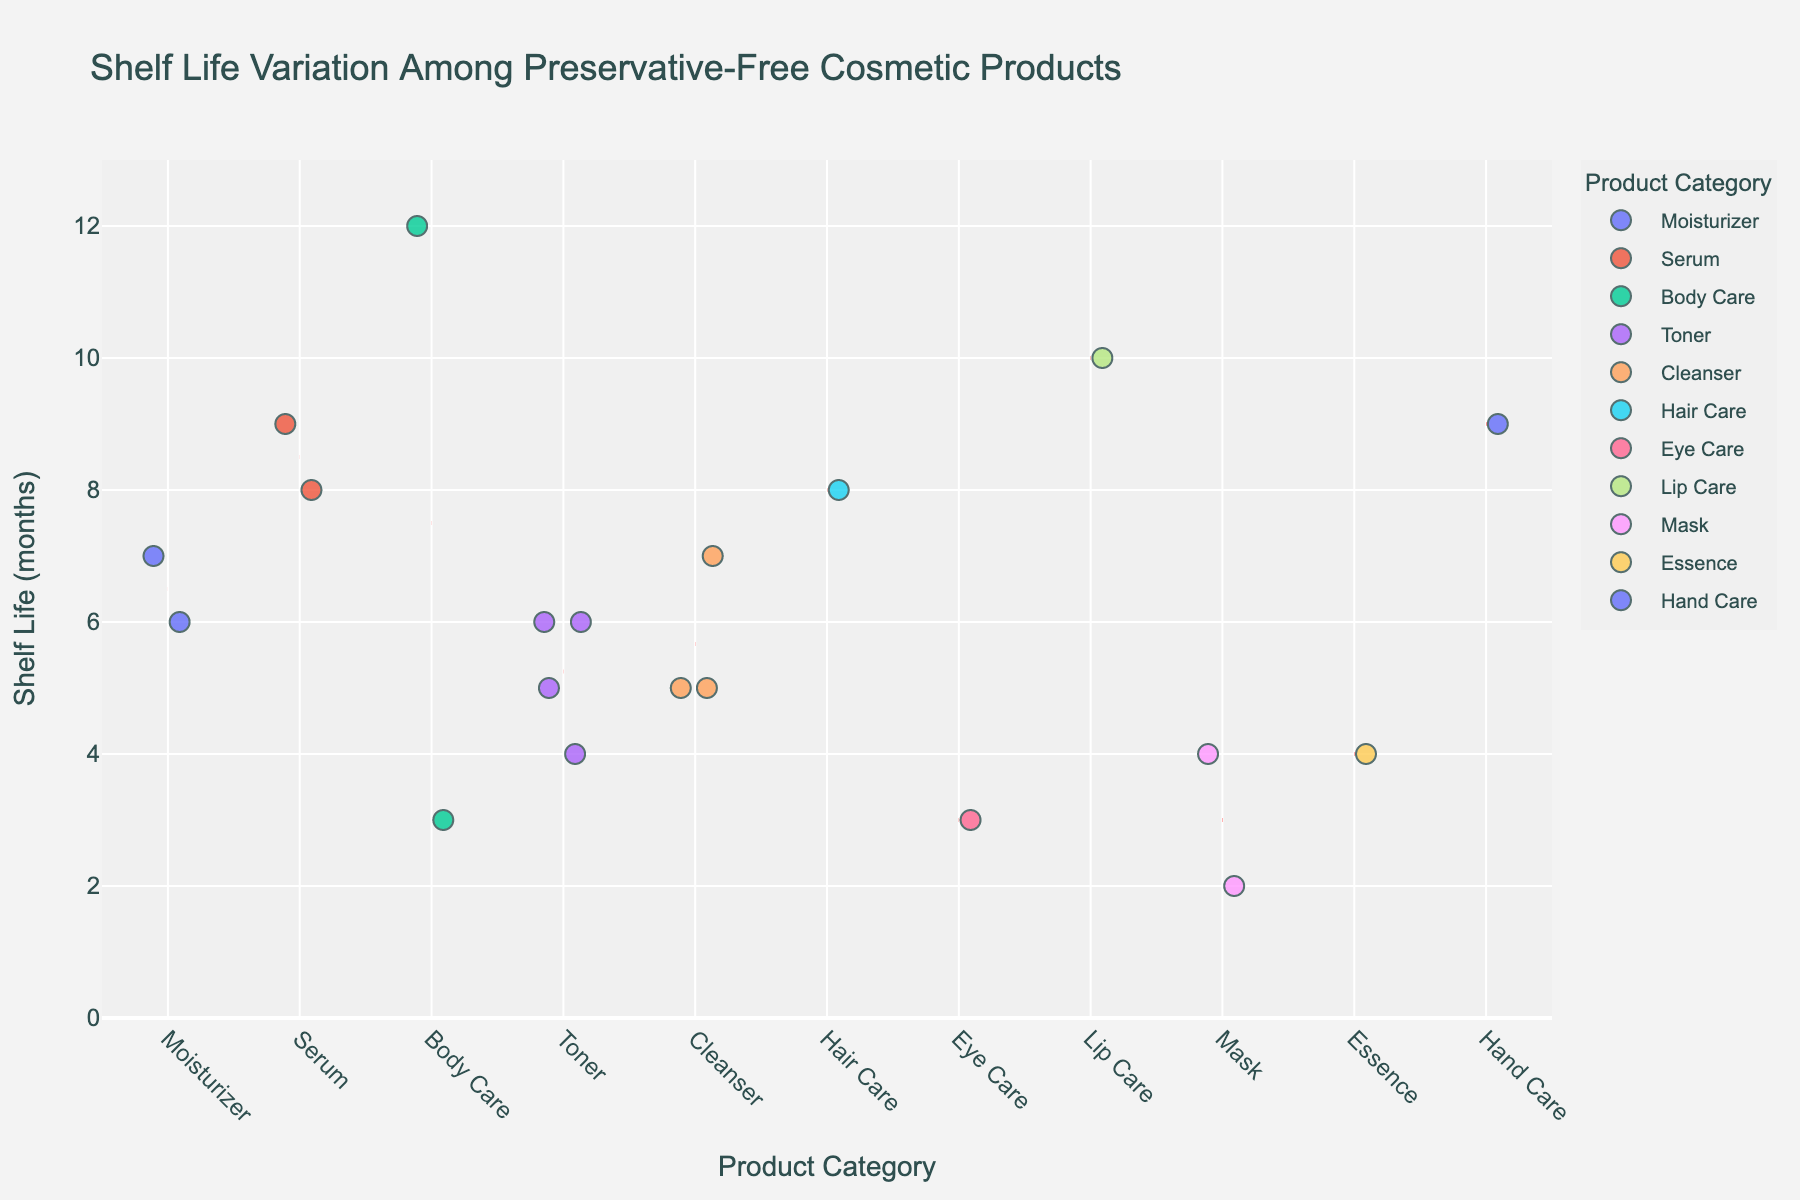What's the title of the plot? The title is presented at the top of the plot and generally summarizes the content of the data represented.
Answer: Shelf Life Variation Among Preservative-Free Cosmetic Products How are the data points in the plot colored? Each data point is colored based on its product category, making it easier to distinguish between different categories.
Answer: By product category Which category has the widest range of shelf life? Inspect the spread of data points along the y-axis for each category. The category with the most vertically dispersed points has the widest range.
Answer: Cleanser What is the mean shelf life for the Moisturizer category? There's a dotted line indicating the mean shelf life for each category. Identify the position of this line for the Moisturizer category on the y-axis.
Answer: 6.5 months Which product has the shortest shelf life and what category is it in? Look for the data point at the lowest position on the y-axis and note its corresponding product and category from the hover data.
Answer: Avocado Face Mask, Mask What is the maximum shelf life in the Serum category? Observe the highest data point within the Serum category on the y-axis to identify its value.
Answer: 9 months Compare the average shelf life between the Toner and Body Care categories. Which has a higher average? Calculate the mean shelf life for each category based on the positions of their mean lines and compare them.
Answer: Body Care How many products have a shelf life less than 5 months? Count the data points that are positioned below the 5-month mark on the y-axis.
Answer: 6 products What is the median shelf life for the Hair Care category? Arrange the shelf life values within the Hair Care category and find the middle value to determine the median.
Answer: 8 months Is there any category with all its products having shelf life greater than 6 months? Which one? Check if all data points within a category are positioned above the 6-month mark on the y-axis.
Answer: Lip Care 